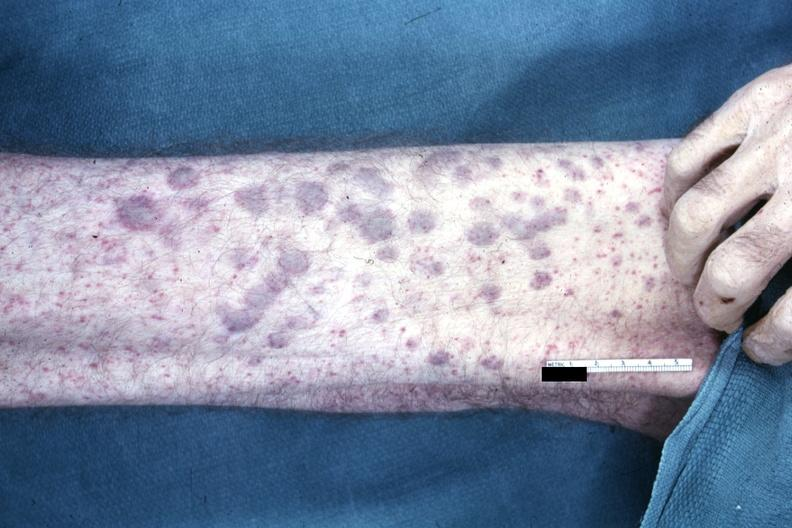does opened muscle show?
Answer the question using a single word or phrase. No 